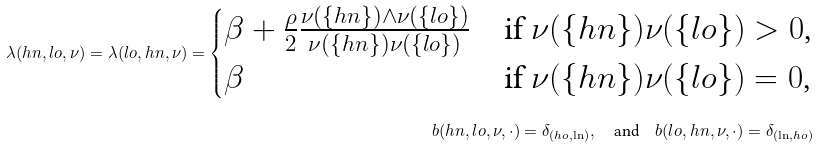Convert formula to latex. <formula><loc_0><loc_0><loc_500><loc_500>\lambda ( h n , l o , \nu ) = \lambda ( l o , h n , \nu ) = \begin{cases} \beta + \frac { \rho } { 2 } \frac { \nu ( \{ h n \} ) \wedge \nu ( \{ l o \} ) } { \nu ( \{ h n \} ) \nu ( \{ l o \} ) } & \text {if     $\nu(\{hn\})\nu(\{lo\})>0$,} \\ \beta & \text {if $\nu(\{hn\})\nu(\{lo\})=0$,} \end{cases} \\ b ( h n , l o , \nu , \cdot ) = \delta _ { ( h o , \ln ) } , \quad \text {and} \quad b ( l o , h n , \nu , \cdot ) = \delta _ { ( \ln , h o ) }</formula> 